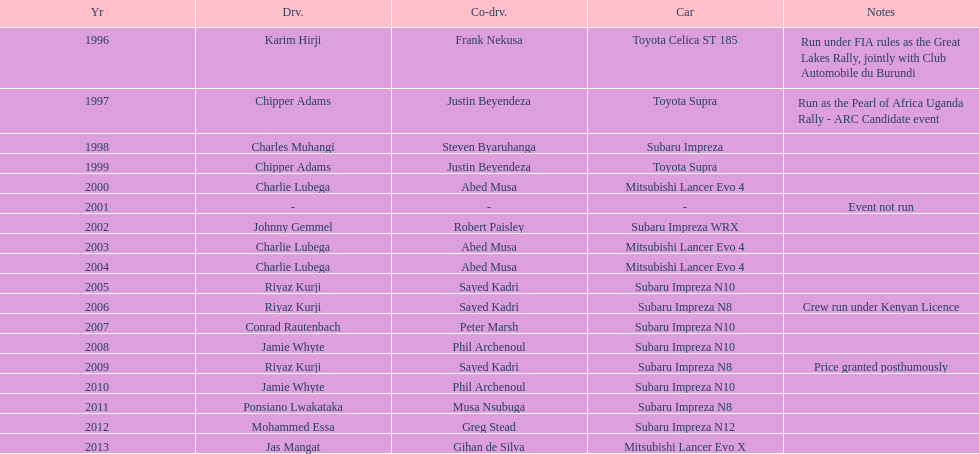How many drivers have secured a win at least twice? 4. 